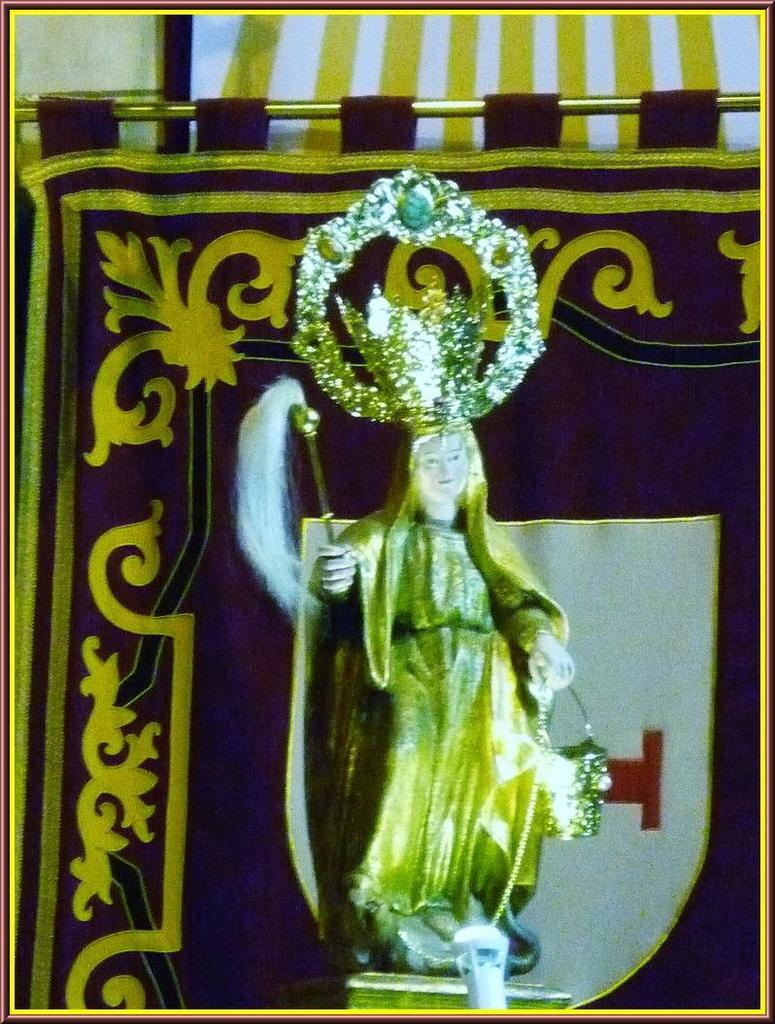What type of statue is depicted in the image? There is a human statue in the image. What position is the statue in? The statue is standing. What is the statue holding in its hand? The statue is holding a stick in its hand. What is the statue wearing on its head? The statue is wearing a crown. What is present in the image besides the statue? There is a curtain in the image. How is the curtain supported in the image? The curtain is hung on an iron pole. How many rabbits are hiding behind the curtain in the image? There are no rabbits present in the image; it only features a human statue and a curtain. 